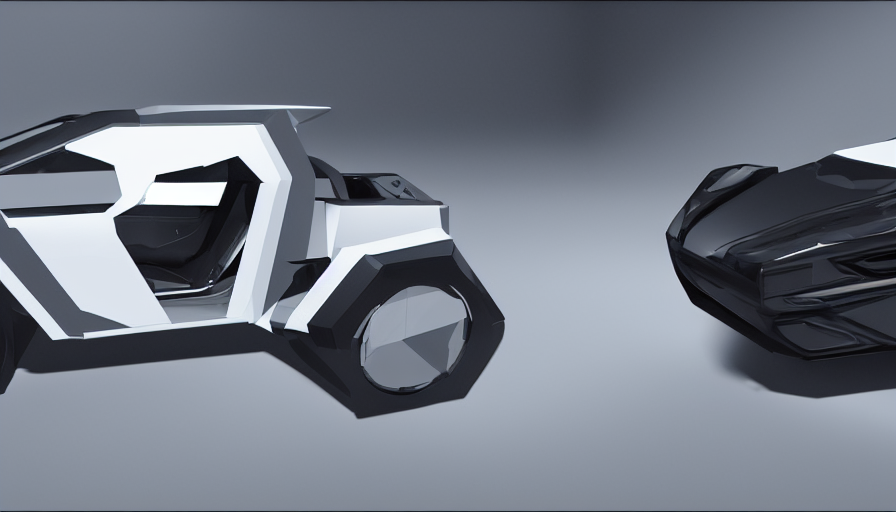Are the fine details and texture clear in the image? Upon examination, the image presents with exceptional clarity. The textures and fine details are indeed very discernible. The reflective surfaces on the objects exhibit smooth gradients and sharp delineations, showcasing the nuanced interplay of light and shadow that reveal the contours and structure of the objects. This high level of clarity contributes to a vivid and tangible sense of the objects' forms and materials. 